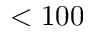Convert formula to latex. <formula><loc_0><loc_0><loc_500><loc_500>< 1 0 0</formula> 